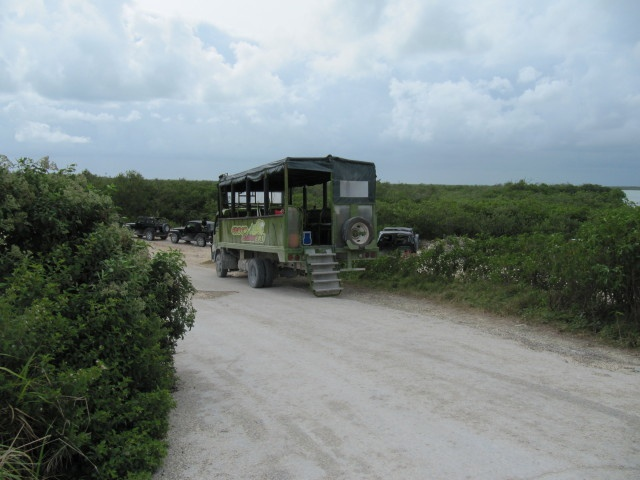Describe the objects in this image and their specific colors. I can see truck in lightblue, black, gray, and darkgreen tones, bus in lightblue, black, gray, and darkgreen tones, car in lightblue, black, gray, and purple tones, car in lightblue, black, and gray tones, and car in lightblue, black, gray, and purple tones in this image. 